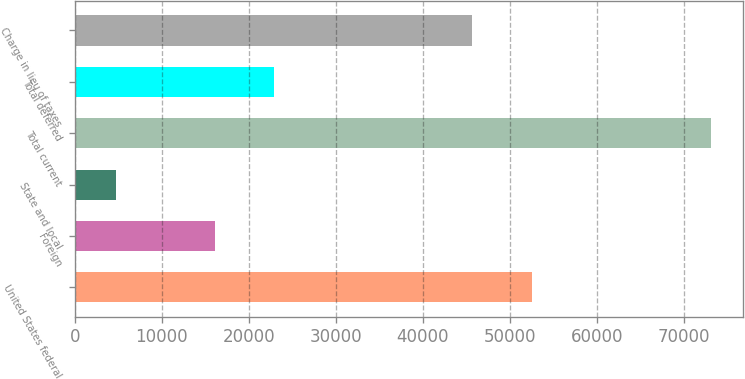Convert chart to OTSL. <chart><loc_0><loc_0><loc_500><loc_500><bar_chart><fcel>United States federal<fcel>Foreign<fcel>State and local<fcel>Total current<fcel>Total deferred<fcel>Charge in lieu of taxes<nl><fcel>52536.2<fcel>16087<fcel>4753<fcel>73195<fcel>22931.2<fcel>45692<nl></chart> 